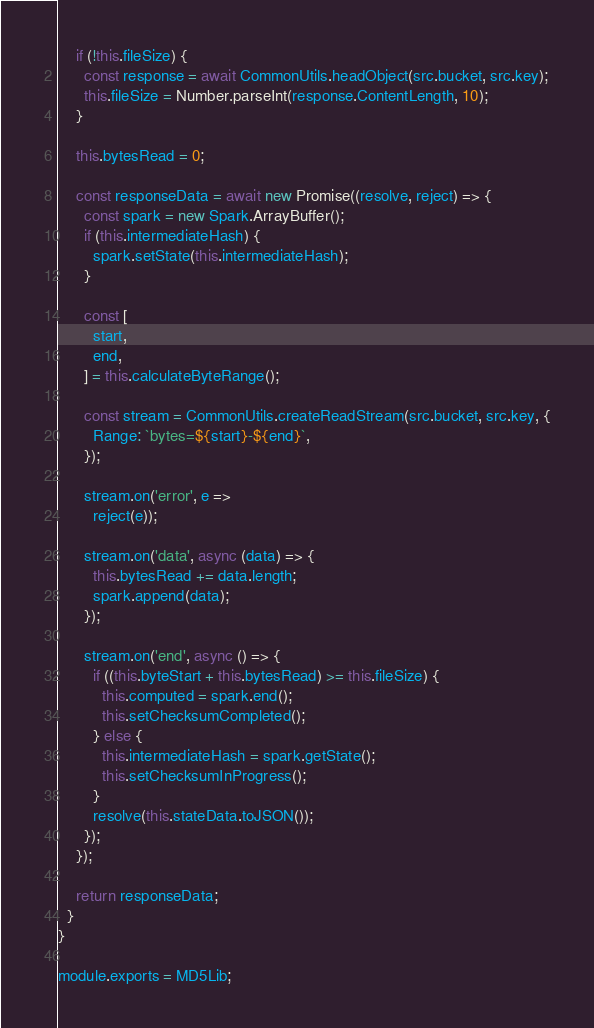<code> <loc_0><loc_0><loc_500><loc_500><_JavaScript_>
    if (!this.fileSize) {
      const response = await CommonUtils.headObject(src.bucket, src.key);
      this.fileSize = Number.parseInt(response.ContentLength, 10);
    }

    this.bytesRead = 0;

    const responseData = await new Promise((resolve, reject) => {
      const spark = new Spark.ArrayBuffer();
      if (this.intermediateHash) {
        spark.setState(this.intermediateHash);
      }

      const [
        start,
        end,
      ] = this.calculateByteRange();

      const stream = CommonUtils.createReadStream(src.bucket, src.key, {
        Range: `bytes=${start}-${end}`,
      });

      stream.on('error', e =>
        reject(e));

      stream.on('data', async (data) => {
        this.bytesRead += data.length;
        spark.append(data);
      });

      stream.on('end', async () => {
        if ((this.byteStart + this.bytesRead) >= this.fileSize) {
          this.computed = spark.end();
          this.setChecksumCompleted();
        } else {
          this.intermediateHash = spark.getState();
          this.setChecksumInProgress();
        }
        resolve(this.stateData.toJSON());
      });
    });

    return responseData;
  }
}

module.exports = MD5Lib;
</code> 